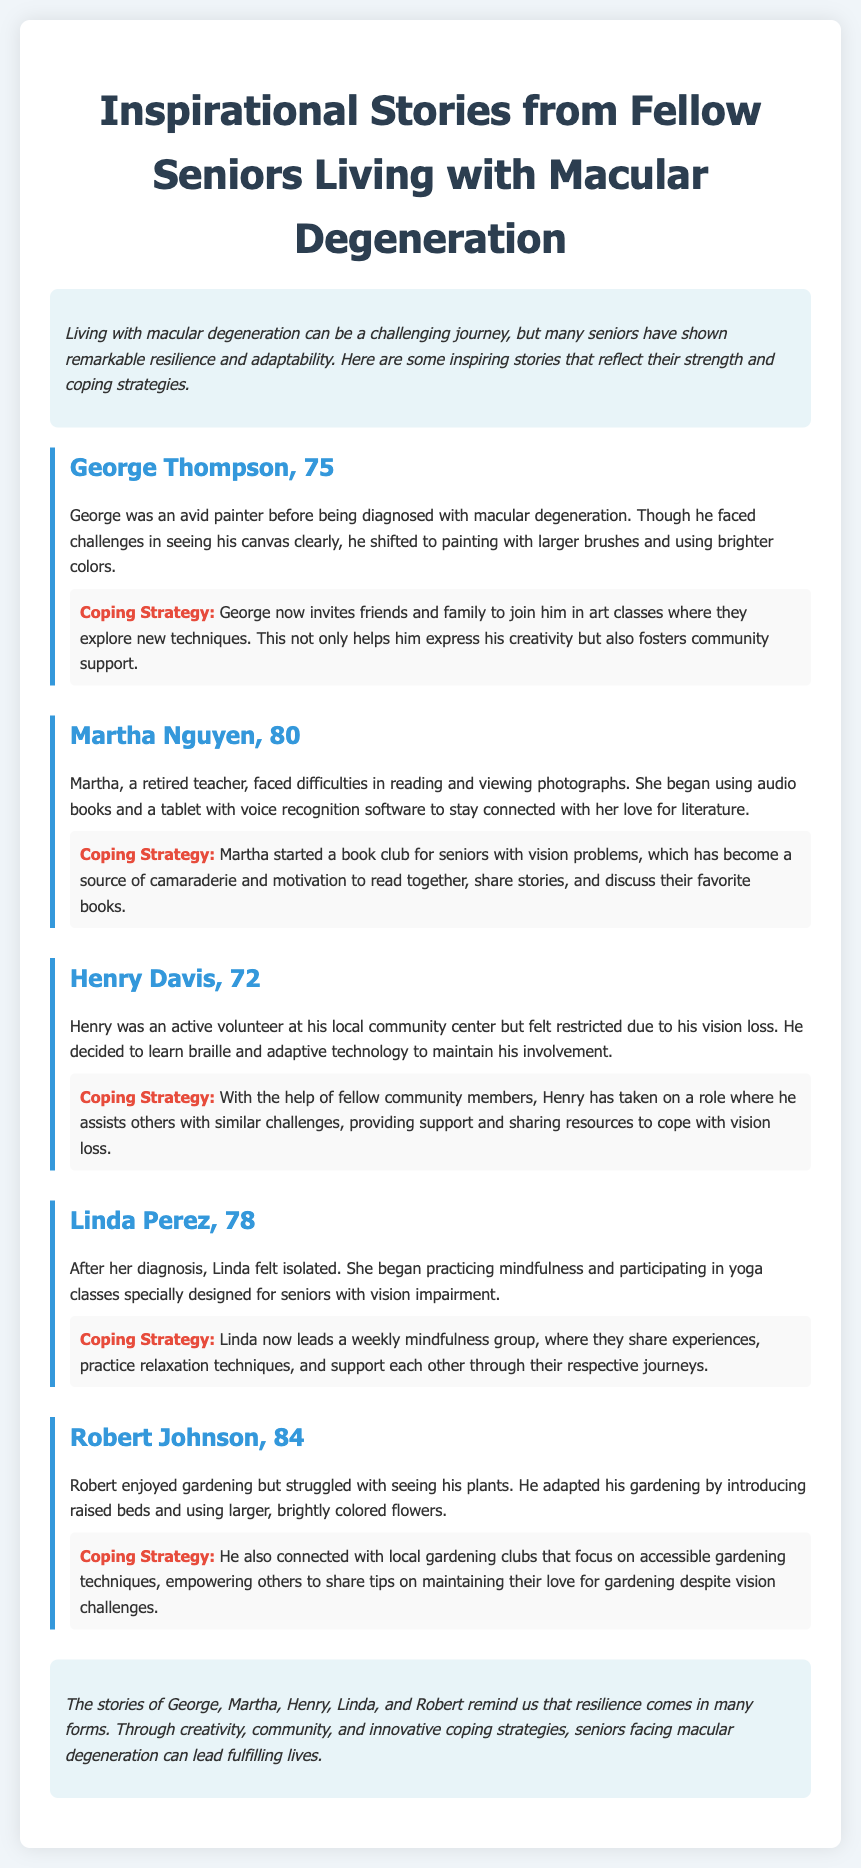what is the age of George Thompson? George Thompson's age is mentioned as 75 years old in the story.
Answer: 75 how does Martha Nguyen stay connected with literature? Martha uses audio books and a tablet with voice recognition software to enjoy literature despite her vision difficulties.
Answer: audio books and voice recognition software what coping strategy does Henry Davis use? Henry learned braille and adaptive technology to maintain his involvement in volunteering despite his vision loss.
Answer: learned braille and adaptive technology how does Linda Perez support others? Linda leads a weekly mindfulness group to share experiences and practice relaxation techniques with others facing similar challenges.
Answer: leads a weekly mindfulness group what gardening adaptation did Robert Johnson make? Robert introduced raised beds and used larger, brightly colored flowers to make gardening easier despite his vision challenges.
Answer: raised beds and larger, brightly colored flowers what is a common theme among the stories? The theme of resilience and adaptability is evident as each individual finds unique coping strategies to navigate the challenges of macular degeneration.
Answer: resilience and adaptability 